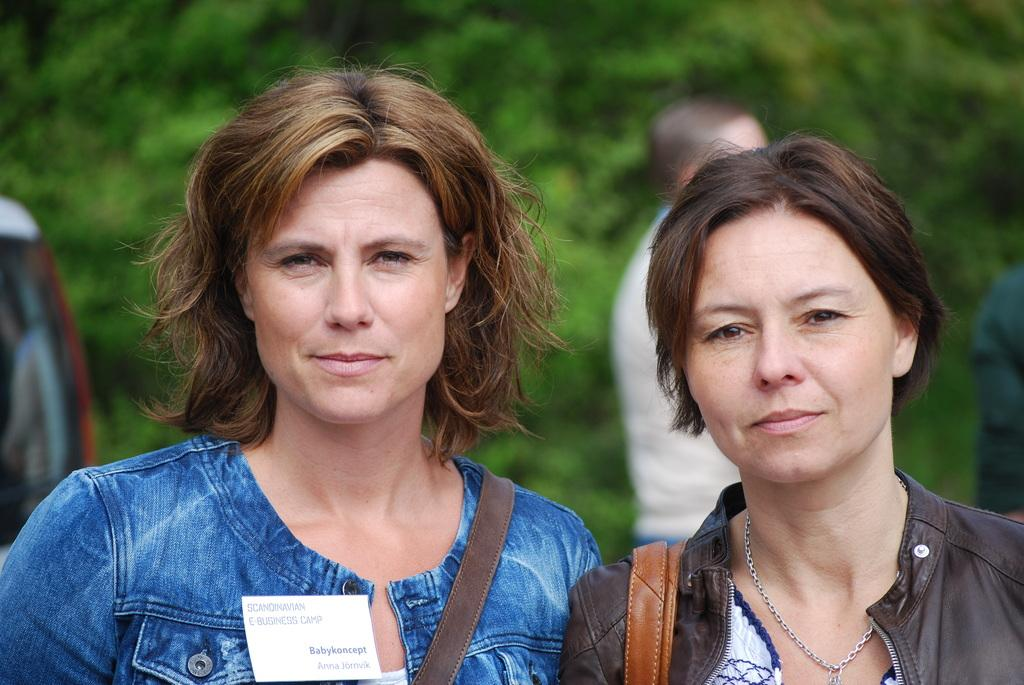How many women are present in the image? There are two women in the image. Can you describe the person in the background of the image? There is a person standing in the background of the image. What can be said about the background of the image? The background of the image is blurred. What type of brake is being used by the zoo animals in the image? There are no zoo animals or brakes present in the image. What is the oven used for in the image? There is no oven present in the image. 